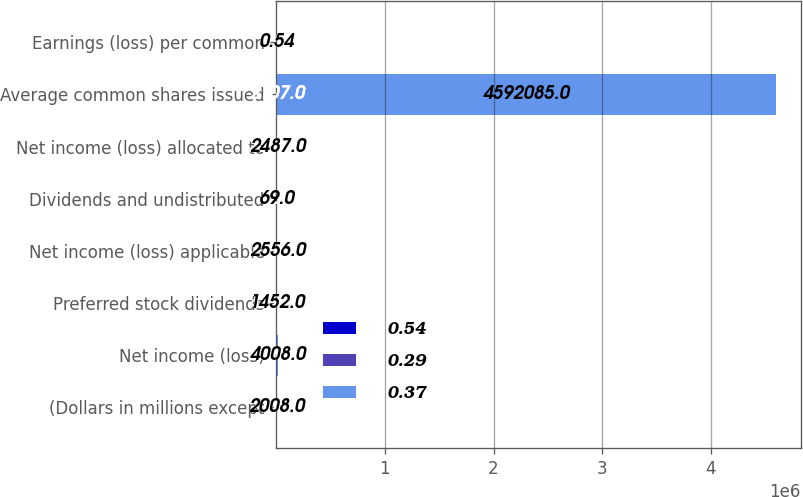<chart> <loc_0><loc_0><loc_500><loc_500><stacked_bar_chart><ecel><fcel>(Dollars in millions except<fcel>Net income (loss)<fcel>Preferred stock dividends<fcel>Net income (loss) applicable<fcel>Dividends and undistributed<fcel>Net income (loss) allocated to<fcel>Average common shares issued<fcel>Earnings (loss) per common<nl><fcel>0.54<fcel>2010<fcel>2238<fcel>1357<fcel>3595<fcel>4<fcel>3599<fcel>2107<fcel>0.37<nl><fcel>0.29<fcel>2009<fcel>6276<fcel>4494<fcel>2204<fcel>6<fcel>2210<fcel>2107<fcel>0.29<nl><fcel>0.37<fcel>2008<fcel>4008<fcel>1452<fcel>2556<fcel>69<fcel>2487<fcel>4.59208e+06<fcel>0.54<nl></chart> 